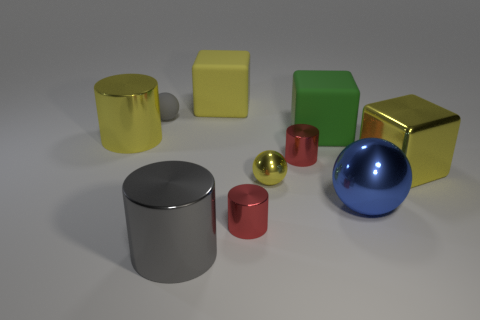Subtract all yellow cylinders. How many yellow blocks are left? 2 Subtract all matte blocks. How many blocks are left? 1 Subtract all gray cylinders. How many cylinders are left? 3 Subtract 2 blocks. How many blocks are left? 1 Subtract all cylinders. How many objects are left? 6 Subtract all big yellow metal blocks. Subtract all yellow rubber objects. How many objects are left? 8 Add 9 small yellow shiny spheres. How many small yellow shiny spheres are left? 10 Add 6 yellow blocks. How many yellow blocks exist? 8 Subtract 0 red balls. How many objects are left? 10 Subtract all cyan cylinders. Subtract all brown spheres. How many cylinders are left? 4 